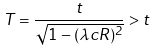Convert formula to latex. <formula><loc_0><loc_0><loc_500><loc_500>T = \frac { t } { \sqrt { 1 - ( \lambda c R ) ^ { 2 } } } > t</formula> 